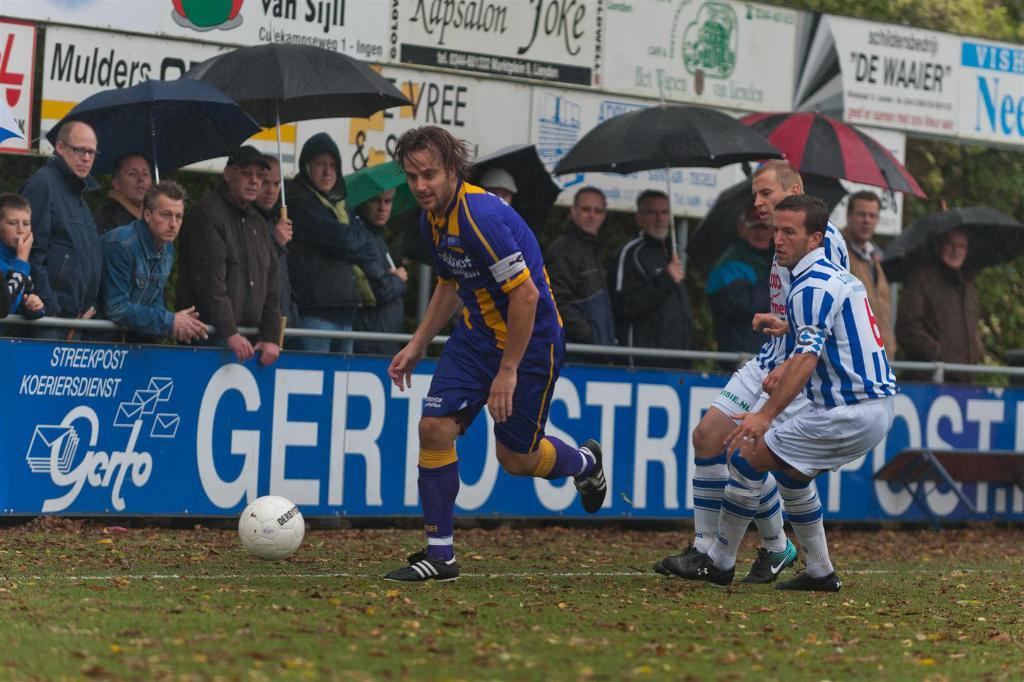<image>
Relay a brief, clear account of the picture shown. soccer players in front of crowd holding umbrella and blue sign with streekpost koeriersdienst on it 